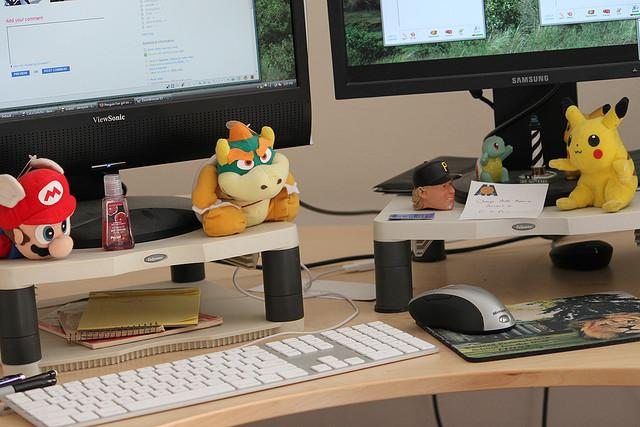What video game does the user of this office space like? super mario 